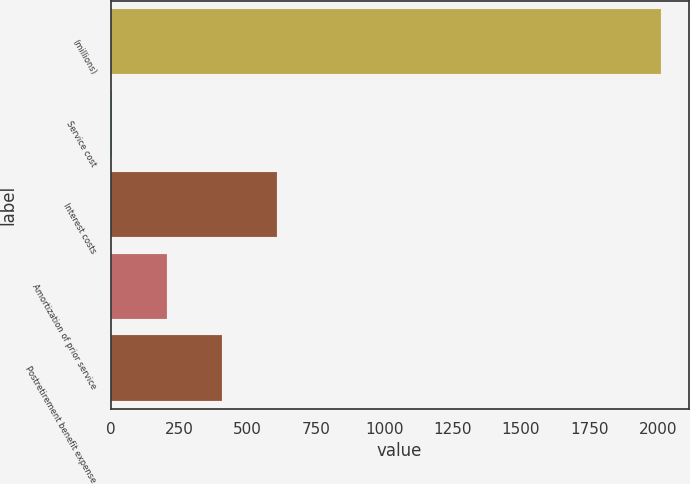Convert chart. <chart><loc_0><loc_0><loc_500><loc_500><bar_chart><fcel>(millions)<fcel>Service cost<fcel>Interest costs<fcel>Amortization of prior service<fcel>Postretirement benefit expense<nl><fcel>2012<fcel>4<fcel>606.4<fcel>204.8<fcel>405.6<nl></chart> 